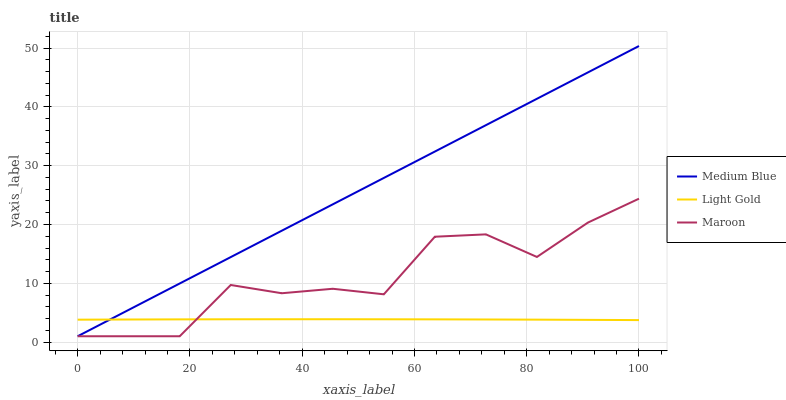Does Light Gold have the minimum area under the curve?
Answer yes or no. Yes. Does Medium Blue have the maximum area under the curve?
Answer yes or no. Yes. Does Maroon have the minimum area under the curve?
Answer yes or no. No. Does Maroon have the maximum area under the curve?
Answer yes or no. No. Is Medium Blue the smoothest?
Answer yes or no. Yes. Is Maroon the roughest?
Answer yes or no. Yes. Is Maroon the smoothest?
Answer yes or no. No. Is Medium Blue the roughest?
Answer yes or no. No. Does Medium Blue have the lowest value?
Answer yes or no. Yes. Does Medium Blue have the highest value?
Answer yes or no. Yes. Does Maroon have the highest value?
Answer yes or no. No. Does Maroon intersect Medium Blue?
Answer yes or no. Yes. Is Maroon less than Medium Blue?
Answer yes or no. No. Is Maroon greater than Medium Blue?
Answer yes or no. No. 